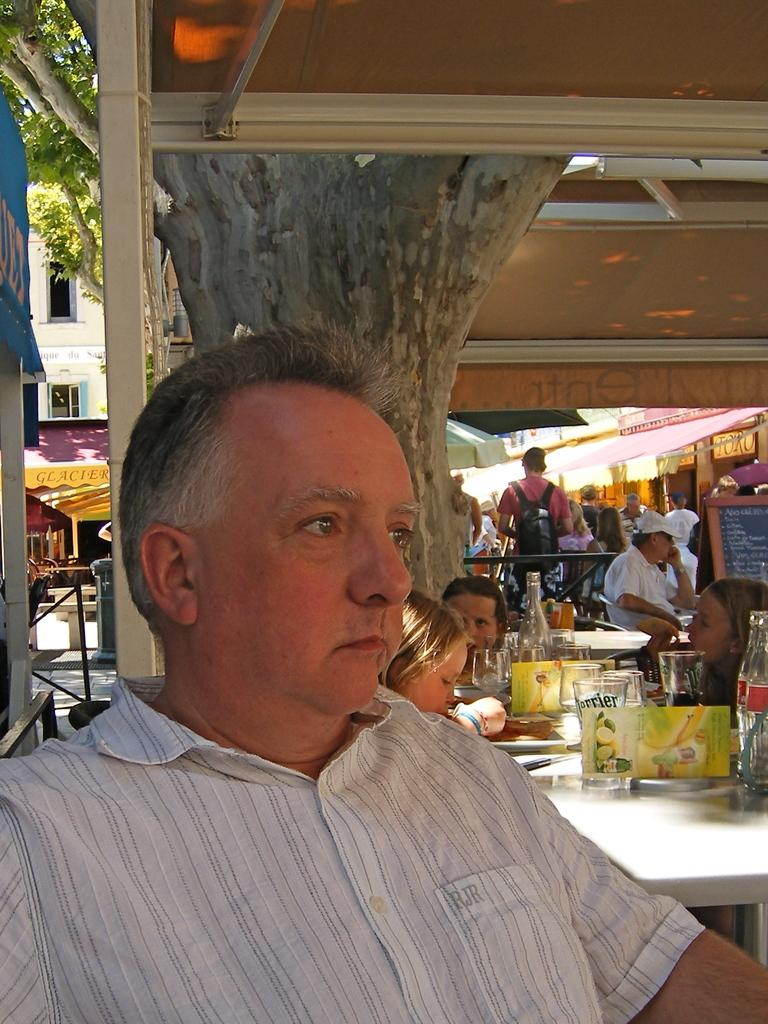How many people are in the image? There is a group of people in the image, but the exact number is not specified. What type of furniture is present in the image? There are tables in the image. What type of containers are visible in the image? There are glasses and bottles in the image. What can be used to identify the location or event in the image? There is a name board in the image. What type of temporary shelter is present in the image? There are tents in the image. What type of natural vegetation is present in the image? There are trees in the image. What other unspecified objects are present in the image? There are some unspecified objects in the image. What type of structure can be seen in the background of the image? There is a building in the background of the image. What type of house is visible in the image? There is no house present in the image. What trick can be performed with the unspecified objects? There is no trick mentioned or implied in the image. 